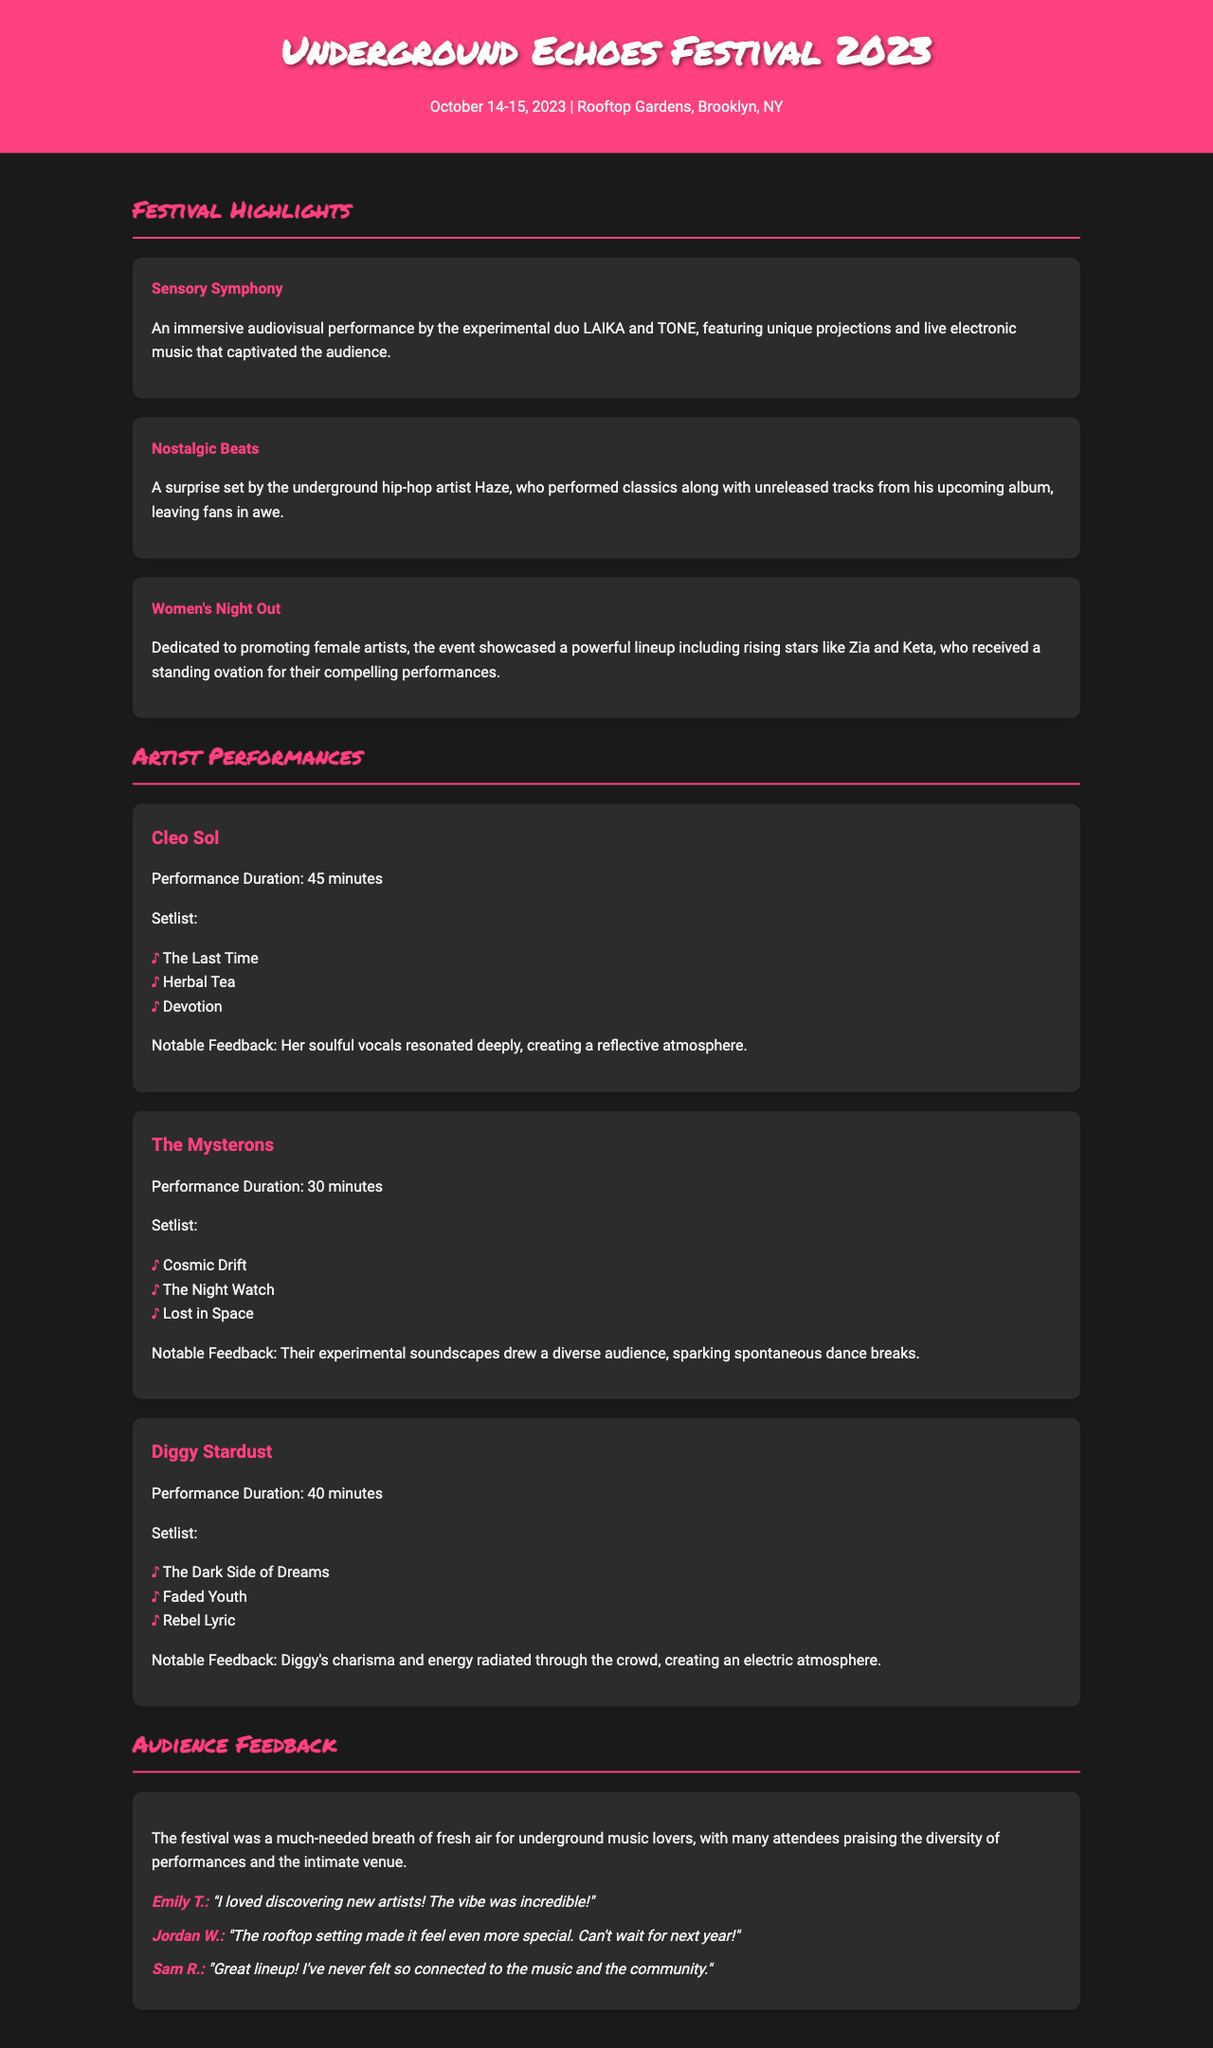what were the dates of the festival? The document specifies the festival took place on October 14-15, 2023.
Answer: October 14-15, 2023 who performed "Herbal Tea"? This song was performed by Cleo Sol as part of her setlist.
Answer: Cleo Sol which artist had a performance duration of 40 minutes? The document states that Diggy Stardust performed for 40 minutes.
Answer: Diggy Stardust what highlight featured an immersive audiovisual performance? The highlight titled "Sensory Symphony" featured an immersive audiovisual performance.
Answer: Sensory Symphony how many songs did The Mysterons perform? The setlist for The Mysterons includes three songs.
Answer: Three what was a notable feedback comment about Diggy Stardust's performance? The feedback highlighted that his charisma and energy created an electric atmosphere.
Answer: Charisma and energy created an electric atmosphere who received a standing ovation during the festival? The festival showcased female artists such as Zia and Keta, who received a standing ovation.
Answer: Zia and Keta what did many attendees praise about the venue? Attendees praised the diversity of performances and the intimate venue setting.
Answer: Diversity of performances and the intimate venue 